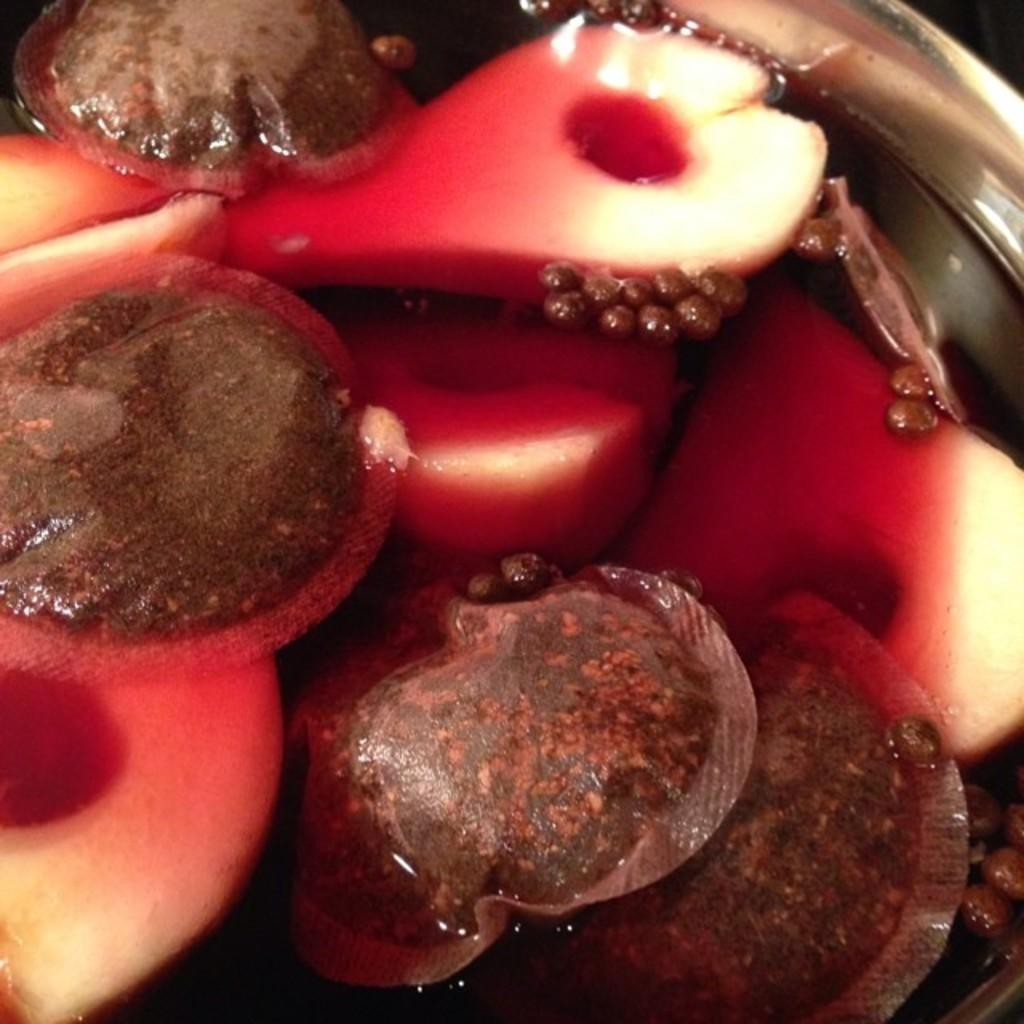What is in the bowl that is visible in the image? There is water in the bowl. Besides water, what other items can be seen in the bowl? There are fruits in the bowl. What type of badge can be seen on the fruits in the image? There are no badges present on the fruits in the image. What type of bedroom can be seen in the image? There is no bedroom present in the image; it features a bowl with water and fruits. 